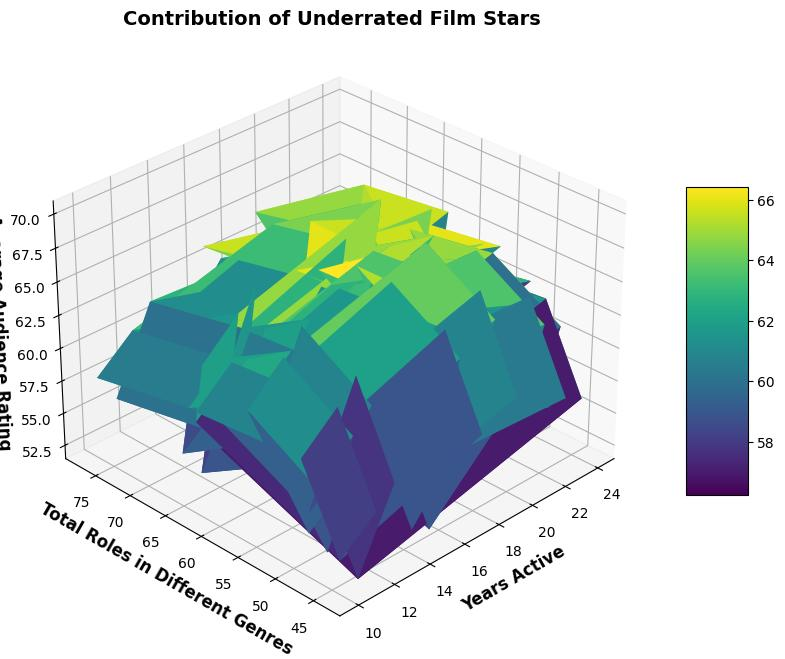What factors contribute to John Doe's rating? The total roles across different genres and years active, when compared with his average audience rating of 7.3, show 25 in action, 10 in drama, 5 in comedy, and 8 in thriller roles over 15 years. His contribution is balanced but skewed towards action.
Answer: Balanced but action-skewed How does Eva Green's average audience rating compare visually in the plot? By looking visually at the plot, Eva Green's 16 years active and the mix of roles with a higher rating of 8.3 should appear as a high peak in the intensity values of the surface plot within her genre contributions.
Answer: High peak Who has the highest number of total roles combined? By adding the values for each actor, Isabella Young has the highest with 30 (action) + 12 (drama) + 20 (comedy) + 15 (thriller) = 77 total roles; this should cause a noticeable increase in years active-span as she also has 21 years active.
Answer: Isabella Young Which actor has the highest rating on the plot and how is this depicted? James Allen, with the highest rating of 8.4; plotted visually, it should create a prominent peak since his roles and years active sustain his high rating.
Answer: James Allen Compare Frank Wright and Grace Hall based on the total number of roles in genres vs. their ratings Frank Wright has 84 total roles vs Grace Hall's 65, but Grace's 7.4 rating on a 14-year span makes for a different perspective versus Frank's longer 22-year span rating of 7.9 in total roles on the plot.
Answer: Frank has more roles, higher rating What is the average of Sophia Perez's total roles in comparison to Daniel Brown's? Sophia Perez has 49 roles total, while Daniel Brown has 61. Averaging their total roles (49 + 61) / 2 = 55 signifies that Daniel’s impact might be visually more widespread but both contribute relative stated ratings.
Answer: 55 How is Olivia Scott's contribution to genres depicted contrastingly with Eva Green's contribution? Olivia Scott's 24 years active with different genre roles totaling fewer (63) roles and a 7.8 rating may span closer in plot relatively, while Eva has 55 roles in 16 years with a higher 8.3 rating creating fewer but higher peaks.
Answer: Olivia has longer span, overall fewer roles Can you distinguish which genre contributions make up Bob Johnson's visual presentation most? As seen, Bob Johnson with a large total of drama roles (20) and dealing from 12 years active changes how ratings may peak across genre contributions. Drama mostly contributing visually.
Answer: Drama How does the impact in roles between action and comedy compare between Liam Harris and Grace Hall? Liam Harris’ 20 action roles vs. Grace Hall’s equal 25 in action and different but globally lighter roles in comedy should both visually distinguish and impact on the surface.
Answer: Grace Hall Who among the stars with over 20 years active, have relatively lower but overall still high audience ratings? Frank Wright, Isabella Young relate such criteria, depicting in the visual plot with longer years and combined genre support should reflect substantial audience relation.
Answer: Frank Wright, Isabella Young 